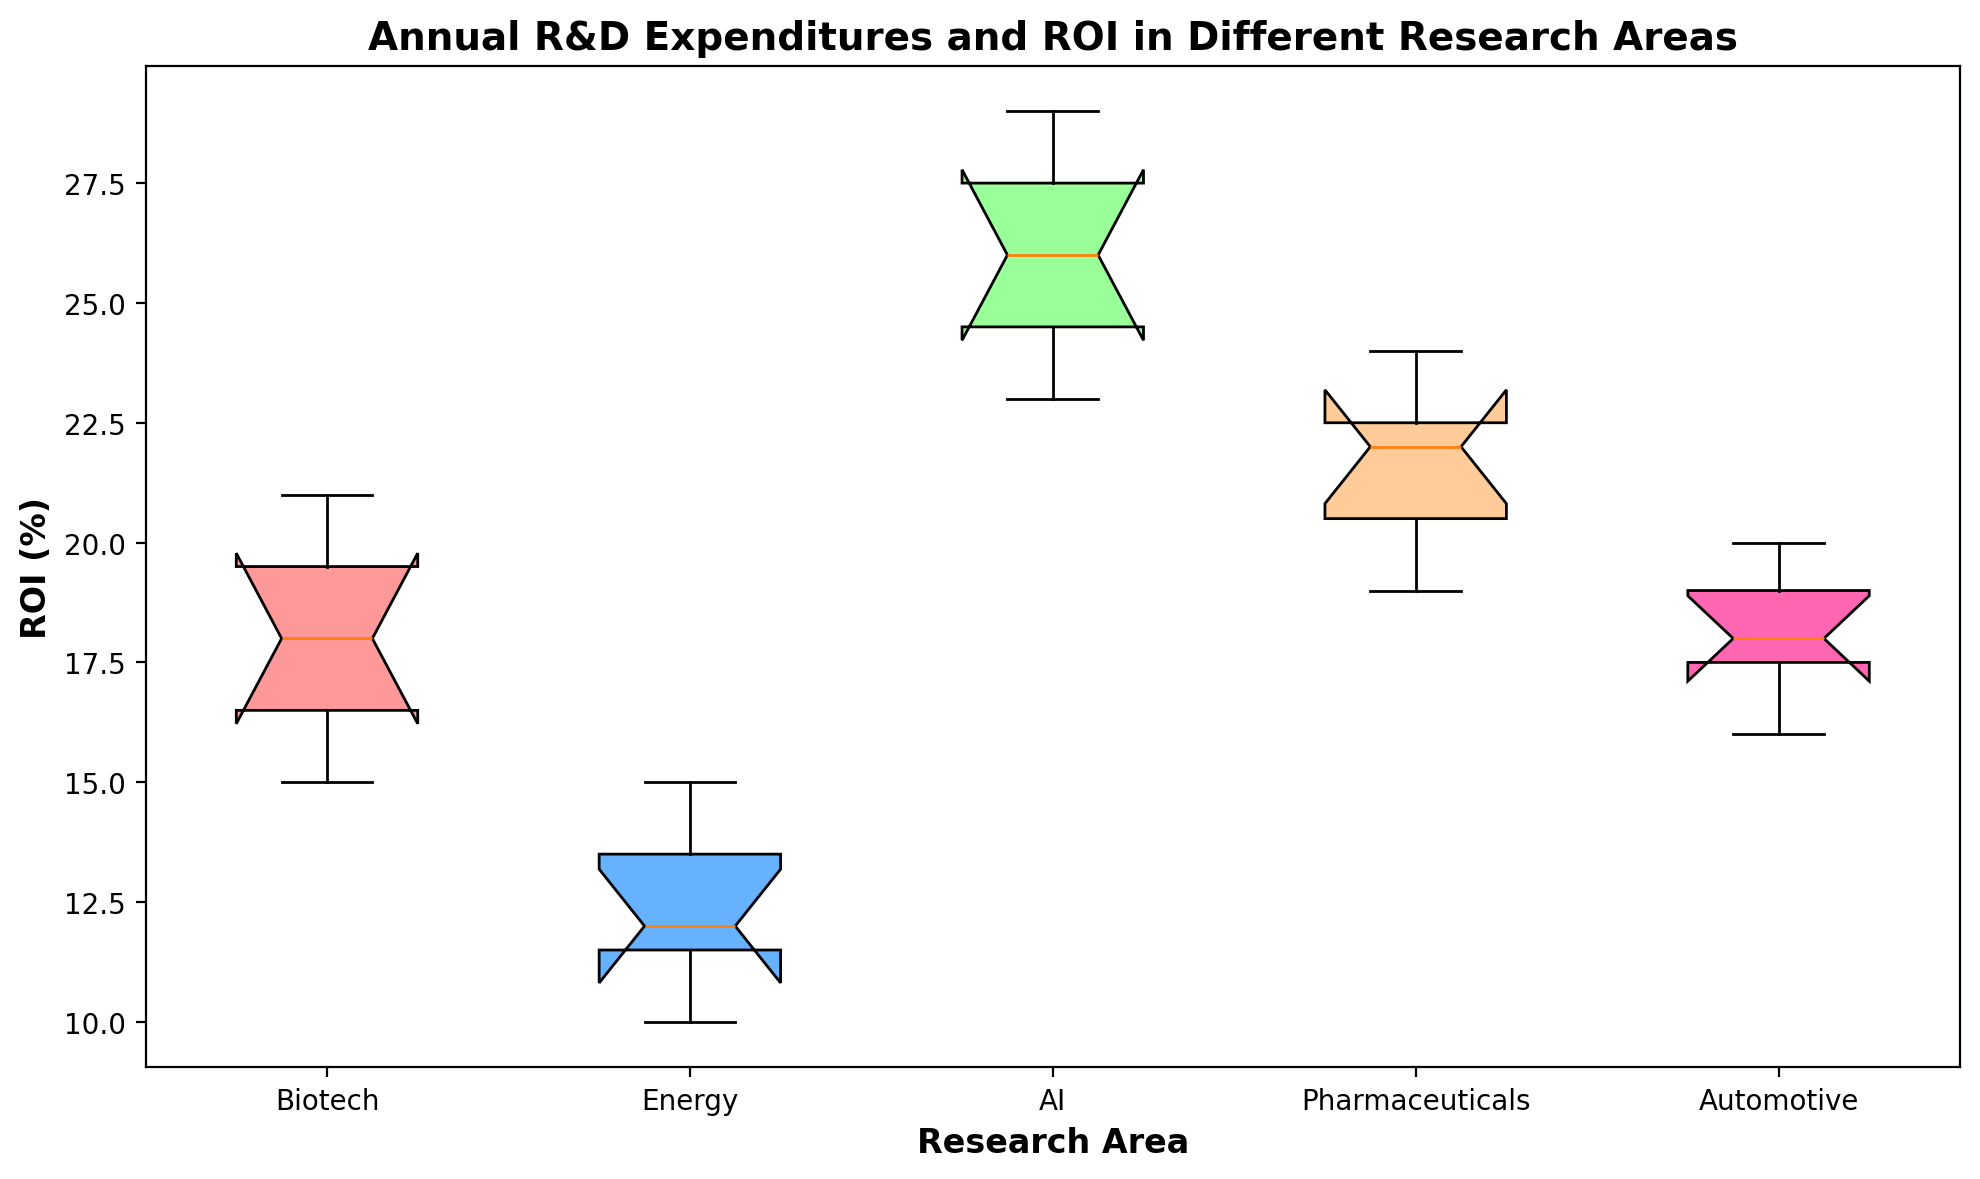Which research area has the highest median ROI? First, identify the median (middle) value of ROI for each research area from the box plot. Compare these median values. The highest median value is in the AI research area.
Answer: AI What is the approximate interquartile range (IQR) of ROI for the Biotech research area? To estimate the IQR, observe the box (middle 50%) for Biotech. The range between the upper quartile (75th percentile) and lower quartile (25th percentile) forms the IQR. Approximate these values from the box plot. The IQR for Biotech is around 4% (from 17% to 21%).
Answer: 4% Which research area has the smallest range of ROI values? Examine the ranges (whiskers) of each box plot and determine which has the smallest span from minimum to maximum values. The smallest range is observed in the Energy research area.
Answer: Energy Are the ROIs of the AI research area generally higher than the ROIs of the Energy research area? Compare the positions of the boxes representing AI and Energy. The AI’s entire box is higher on the ROI scale compared to Energy’s box, indicating that AI generally has higher ROIs.
Answer: Yes Which research area has the widest range between its lower quartile and its upper whisker? Assess the distance from the lower quartile to the upper whisker (max value) for each research area. The research area with the widest range is Pharmaceuticals.
Answer: Pharmaceuticals By how much does the upper quartile of ROI in Automotive surpass the median ROI in Energy? Estimate the upper quartile value for Automotive and the median ROI for Energy from the plot. Taking their difference shows that the upper quartile in Automotive surpasses the median ROI in Energy by about 7% (18% - 11%).
Answer: 7% In which research area is the median ROI closest to 20%? Identify the research area where the line inside the box (median) is around 20%. This research area is Pharmaceuticals.
Answer: Pharmaceuticals Which research areas have an interquartile range of 5% or more? By examining the boxes' (IQRs) heights, find the research areas with an IQR of 5% or greater. Those areas are Biotech, AI, and Automotive.
Answer: Biotech, AI, Automotive 